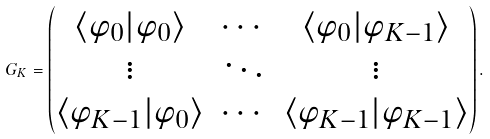<formula> <loc_0><loc_0><loc_500><loc_500>G _ { K } = \begin{pmatrix} \langle \varphi _ { 0 } | \varphi _ { 0 } \rangle & \cdots & \langle \varphi _ { 0 } | \varphi _ { K - 1 } \rangle \\ \vdots & \ddots & \vdots \\ \langle \varphi _ { K - 1 } | \varphi _ { 0 } \rangle & \cdots & \langle \varphi _ { K - 1 } | \varphi _ { K - 1 } \rangle \\ \end{pmatrix} .</formula> 